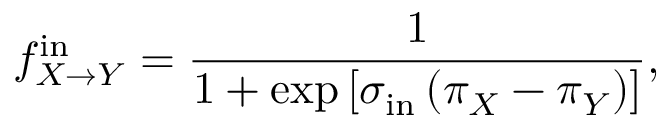<formula> <loc_0><loc_0><loc_500><loc_500>f _ { X \to Y } ^ { i n } = \frac { 1 } { 1 + \exp \left [ \sigma _ { i n } \left ( \pi _ { X } - \pi _ { Y } \right ) \right ] } ,</formula> 